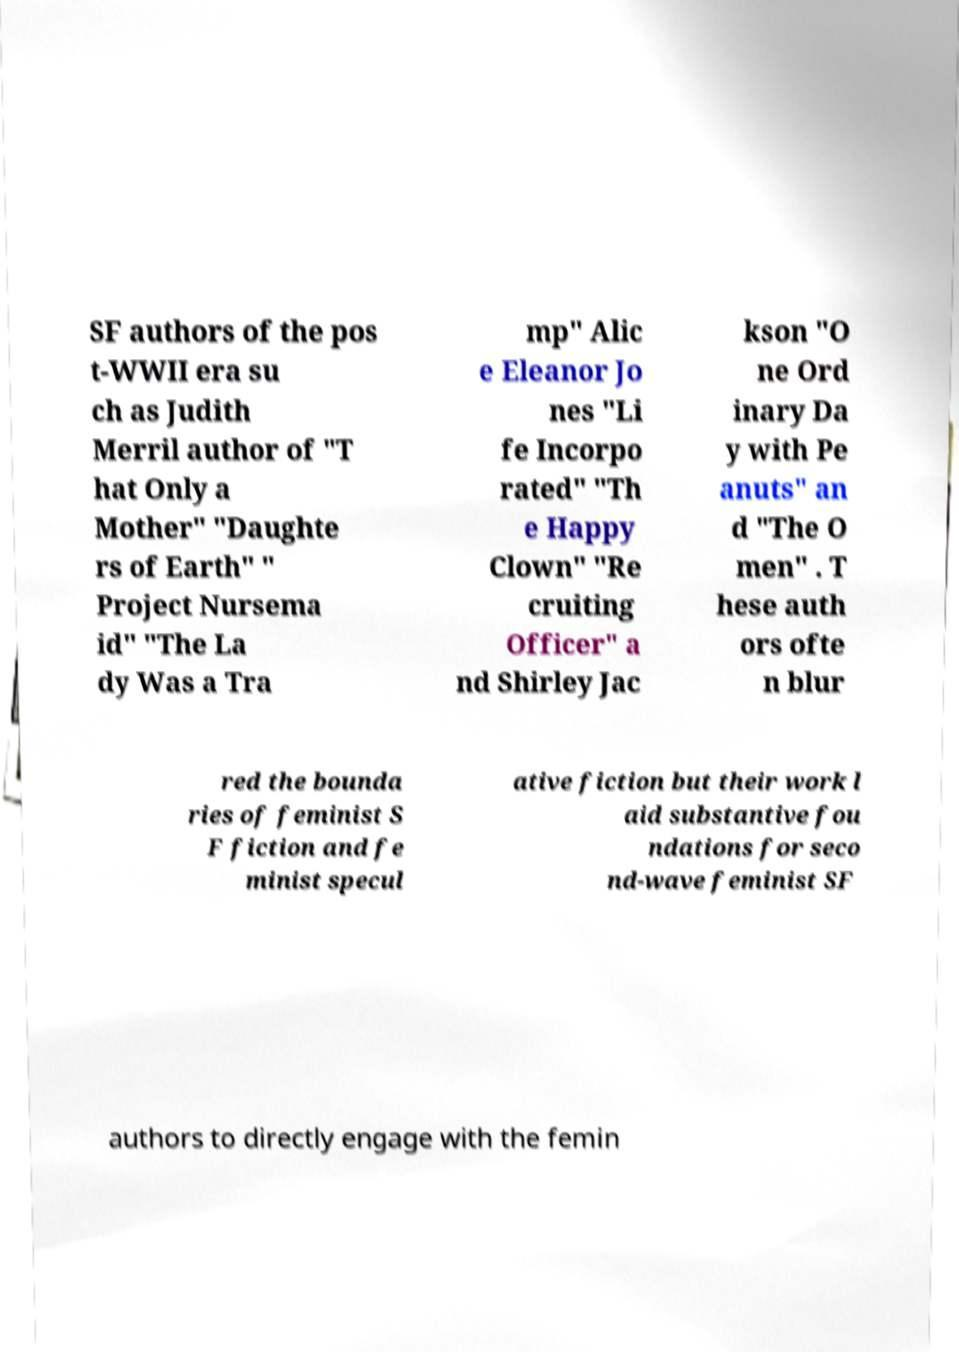Could you extract and type out the text from this image? SF authors of the pos t-WWII era su ch as Judith Merril author of "T hat Only a Mother" "Daughte rs of Earth" " Project Nursema id" "The La dy Was a Tra mp" Alic e Eleanor Jo nes "Li fe Incorpo rated" "Th e Happy Clown" "Re cruiting Officer" a nd Shirley Jac kson "O ne Ord inary Da y with Pe anuts" an d "The O men" . T hese auth ors ofte n blur red the bounda ries of feminist S F fiction and fe minist specul ative fiction but their work l aid substantive fou ndations for seco nd-wave feminist SF authors to directly engage with the femin 